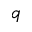<formula> <loc_0><loc_0><loc_500><loc_500>q</formula> 